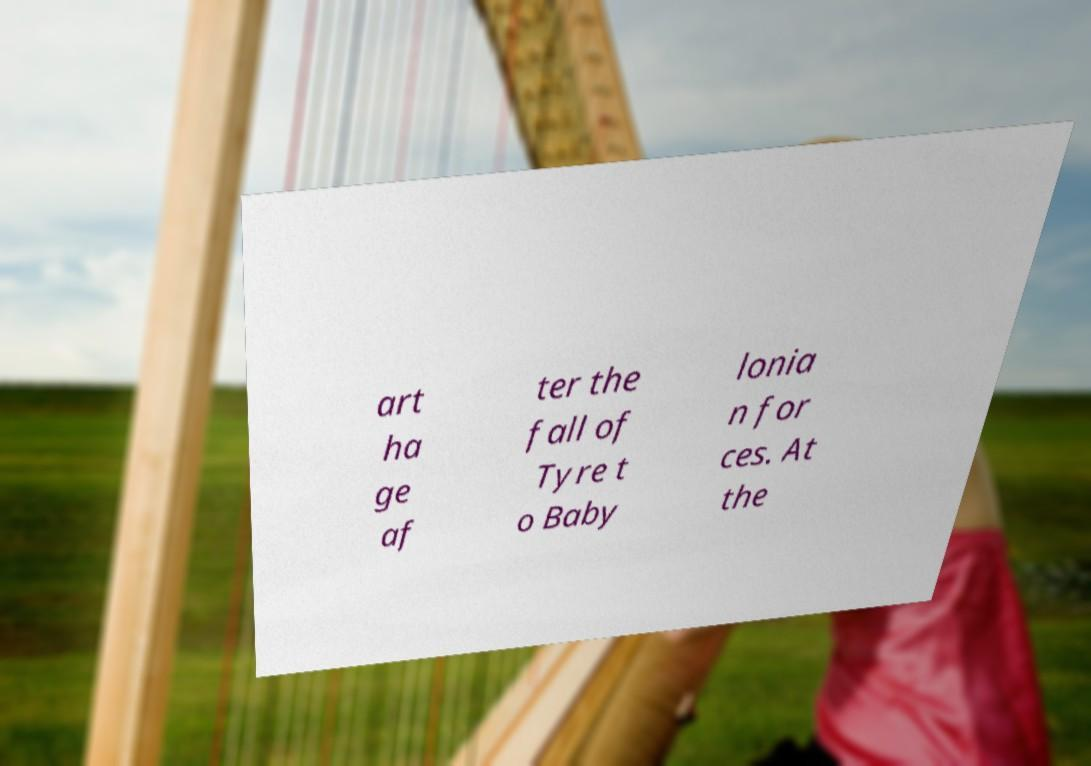Can you read and provide the text displayed in the image?This photo seems to have some interesting text. Can you extract and type it out for me? art ha ge af ter the fall of Tyre t o Baby lonia n for ces. At the 